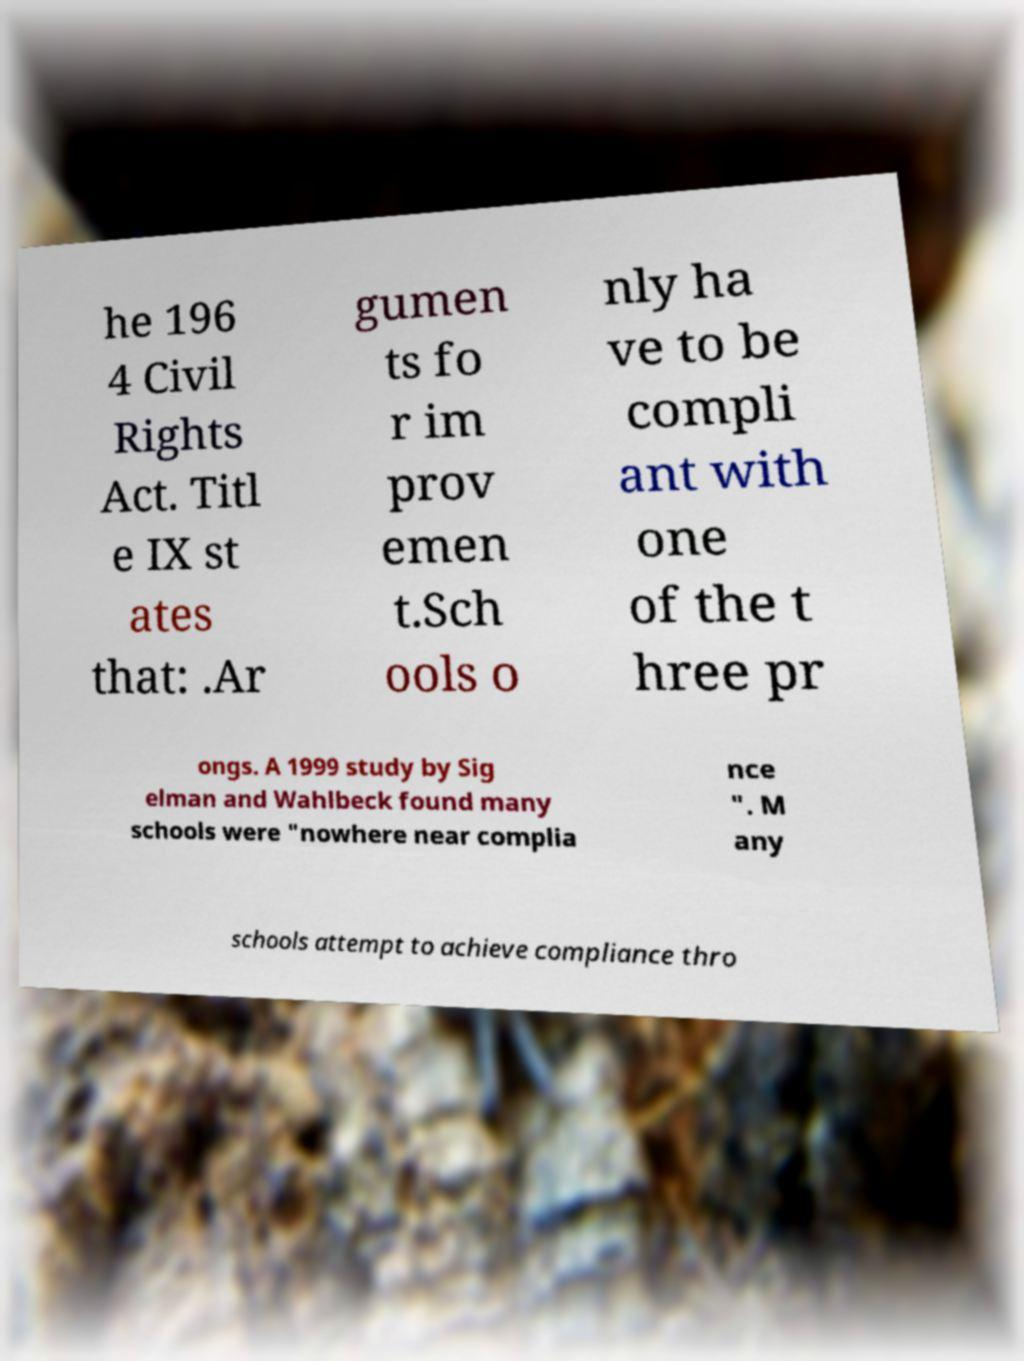What messages or text are displayed in this image? I need them in a readable, typed format. he 196 4 Civil Rights Act. Titl e IX st ates that: .Ar gumen ts fo r im prov emen t.Sch ools o nly ha ve to be compli ant with one of the t hree pr ongs. A 1999 study by Sig elman and Wahlbeck found many schools were "nowhere near complia nce ". M any schools attempt to achieve compliance thro 